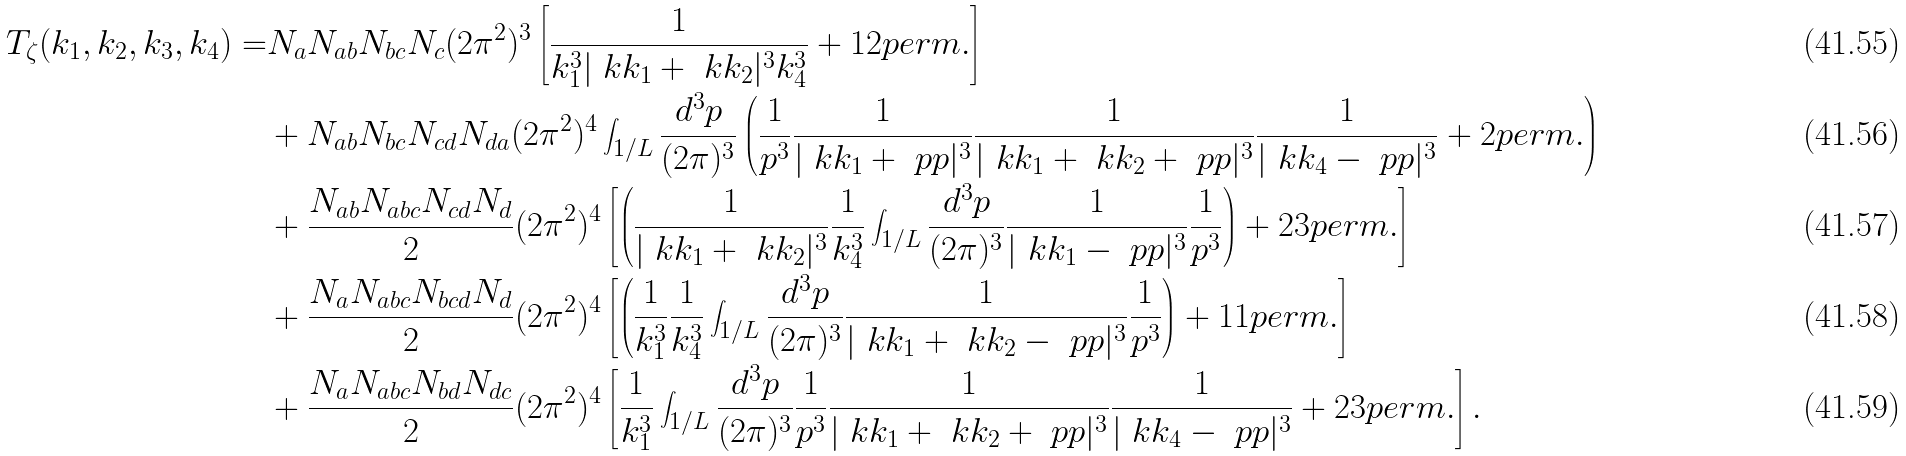<formula> <loc_0><loc_0><loc_500><loc_500>T _ { \zeta } ( k _ { 1 } , k _ { 2 } , k _ { 3 } , k _ { 4 } ) = & N _ { a } N _ { a b } N _ { b c } N _ { c } ( 2 \pi ^ { 2 } ) ^ { 3 } \left [ \frac { 1 } { k _ { 1 } ^ { 3 } | \ k k _ { 1 } + \ k k _ { 2 } | ^ { 3 } k _ { 4 } ^ { 3 } } + 1 2 p e r m . \right ] \\ & + N _ { a b } N _ { b c } N _ { c d } N _ { d a } ( 2 \pi ^ { 2 } ) ^ { 4 } \int _ { 1 / L } \frac { d ^ { 3 } p } { ( 2 \pi ) ^ { 3 } } \left ( \frac { 1 } { p ^ { 3 } } \frac { 1 } { | \ k k _ { 1 } + \ p p | ^ { 3 } } \frac { 1 } { | \ k k _ { 1 } + \ k k _ { 2 } + \ p p | ^ { 3 } } \frac { 1 } { | \ k k _ { 4 } - \ p p | ^ { 3 } } + 2 p e r m . \right ) \\ & + \frac { N _ { a b } N _ { a b c } N _ { c d } N _ { d } } { 2 } ( 2 \pi ^ { 2 } ) ^ { 4 } \left [ \left ( \frac { 1 } { | \ k k _ { 1 } + \ k k _ { 2 } | ^ { 3 } } \frac { 1 } { k _ { 4 } ^ { 3 } } \int _ { 1 / L } \frac { d ^ { 3 } p } { ( 2 \pi ) ^ { 3 } } \frac { 1 } { | \ k k _ { 1 } - \ p p | ^ { 3 } } \frac { 1 } { p ^ { 3 } } \right ) + 2 3 p e r m . \right ] \\ & + \frac { N _ { a } N _ { a b c } N _ { b c d } N _ { d } } { 2 } ( 2 \pi ^ { 2 } ) ^ { 4 } \left [ \left ( \frac { 1 } { k _ { 1 } ^ { 3 } } \frac { 1 } { k _ { 4 } ^ { 3 } } \int _ { 1 / L } \frac { d ^ { 3 } p } { ( 2 \pi ) ^ { 3 } } \frac { 1 } { | \ k k _ { 1 } + \ k k _ { 2 } - \ p p | ^ { 3 } } \frac { 1 } { p ^ { 3 } } \right ) + 1 1 p e r m . \right ] \\ & + \frac { N _ { a } N _ { a b c } N _ { b d } N _ { d c } } { 2 } ( 2 \pi ^ { 2 } ) ^ { 4 } \left [ \frac { 1 } { k _ { 1 } ^ { 3 } } \int _ { 1 / L } \frac { d ^ { 3 } p } { ( 2 \pi ) ^ { 3 } } \frac { 1 } { p ^ { 3 } } \frac { 1 } { | \ k k _ { 1 } + \ k k _ { 2 } + \ p p | ^ { 3 } } \frac { 1 } { | \ k k _ { 4 } - \ p p | ^ { 3 } } + 2 3 p e r m . \right ] .</formula> 